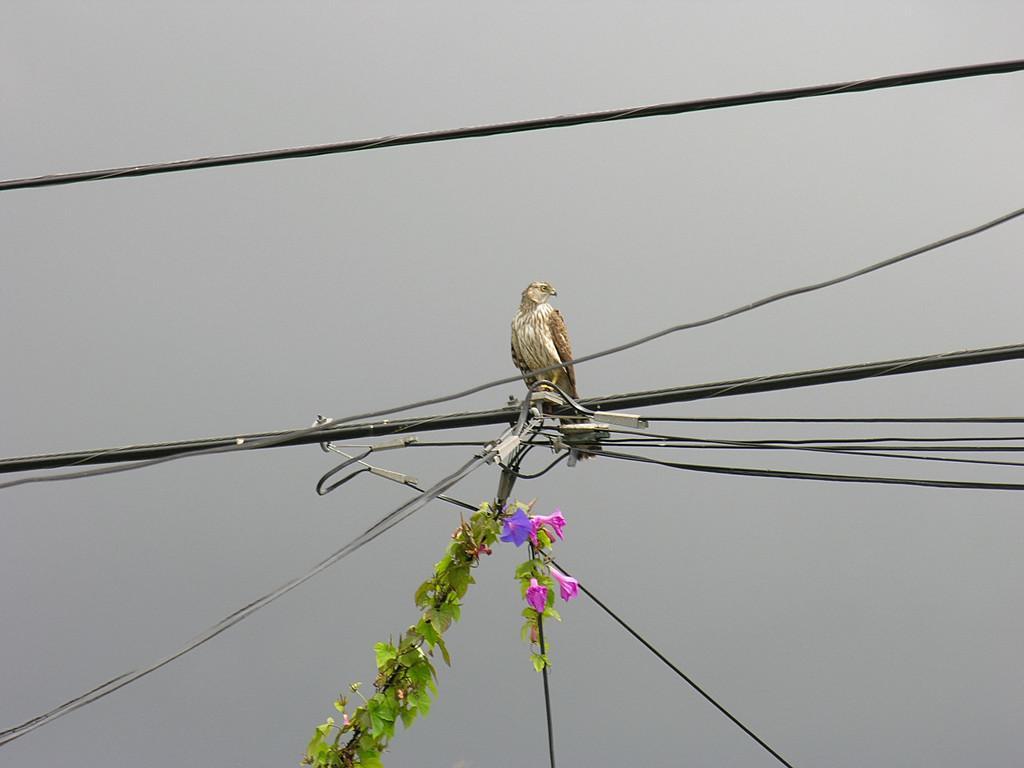How would you summarize this image in a sentence or two? In this picture we can observe a white and brown color bird on the wire. We can observe some wires. There are leaves and pink color flowers. In the background there is a sky. 